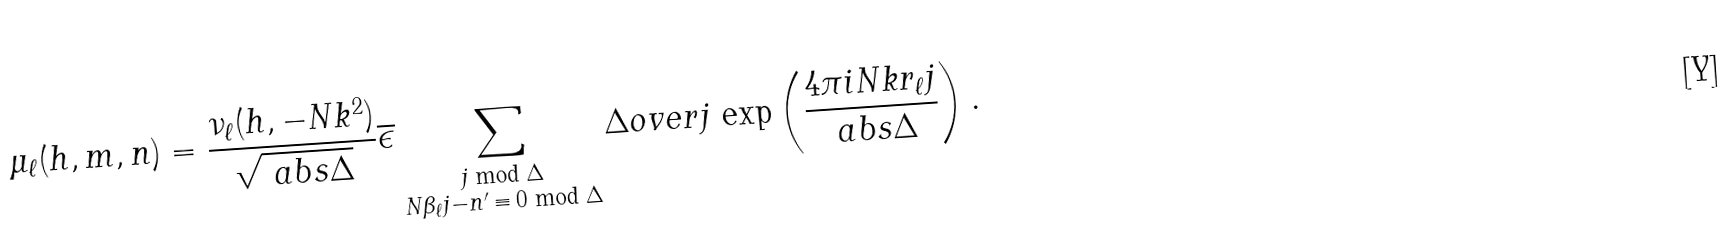<formula> <loc_0><loc_0><loc_500><loc_500>\mu _ { \ell } ( h , m , n ) = \frac { \nu _ { \ell } ( h , - N k ^ { 2 } ) } { \sqrt { \ a b s { \Delta } } } \overline { \epsilon } \sum _ { \substack { j \bmod \Delta \\ N \beta _ { \ell } j - n ^ { \prime } \, \equiv \, 0 \bmod \Delta } } \Delta o v e r { j } \, \exp \left ( { \frac { 4 \pi i N k r _ { \ell } j } { \ a b s { \Delta } } } \right ) .</formula> 